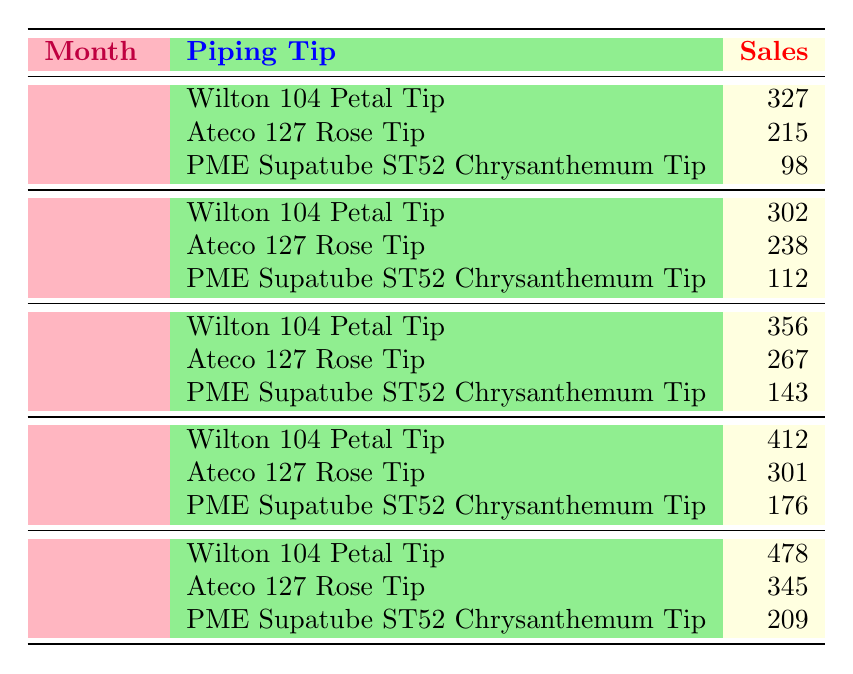What were the sales figures for the 'Ateco 127 Rose Tip' in March? In March, the 'Ateco 127 Rose Tip' had sales of 267 according to the table.
Answer: 267 Which piping tip had the highest sales in May? By examining the sales data for May, the 'Wilton 104 Petal Tip' led with sales of 478.
Answer: Wilton 104 Petal Tip What is the total sales for the 'PME Supatube ST52 Chrysanthemum Tip' from January to April? To find the total sales, sum the individual monthly sales: 98 (January) + 112 (February) + 143 (March) + 176 (April) = 529.
Answer: 529 Did sales of the 'Wilton 104 Petal Tip' increase every month? Analyzing the data, the sales figures for the 'Wilton 104 Petal Tip' were 327 in January, 302 in February, 356 in March, 412 in April, and 478 in May. It shows a decrease from January to February, so the statement is false.
Answer: No What was the average sales for the 'Ateco 127 Rose Tip' over the five months? The sales figures are 215 (January), 238 (February), 267 (March), 301 (April), and 345 (May). First, sum these values: 215 + 238 + 267 + 301 + 345 = 1366. Then divide by 5 for the average: 1366 / 5 = 273.2.
Answer: 273.2 In which month was the 'PME Supatube ST52 Chrysanthemum Tip' sold the least? By examining the sales across all months for the 'PME Supatube ST52 Chrysanthemum Tip', the figures are 98 (January), 112 (February), 143 (March), 176 (April), and 209 (May), showing the least sales in January.
Answer: January What were the total sales for all piping tips in April? To get the total sales for April, add the sales figures: 412 (Wilton 104) + 301 (Ateco 127) + 176 (PME Supatube) = 889.
Answer: 889 Is it true that 'Ateco 127 Rose Tip' consistently sold more than 'PME Supatube ST52 Chrysanthemum Tip'? Comparing the sales, the 'Ateco 127 Rose Tip' had higher sales in January (215 > 98) and February (238 > 112), but March (267 > 143), April (301 > 176), and May (345 > 209) also show higher sales. Thus, the statement is true.
Answer: Yes What is the difference in sales for the 'Wilton 104 Petal Tip' between May and January? The sales for 'Wilton 104 Petal Tip' were 478 in May and 327 in January. The difference is calculated as 478 - 327 = 151.
Answer: 151 